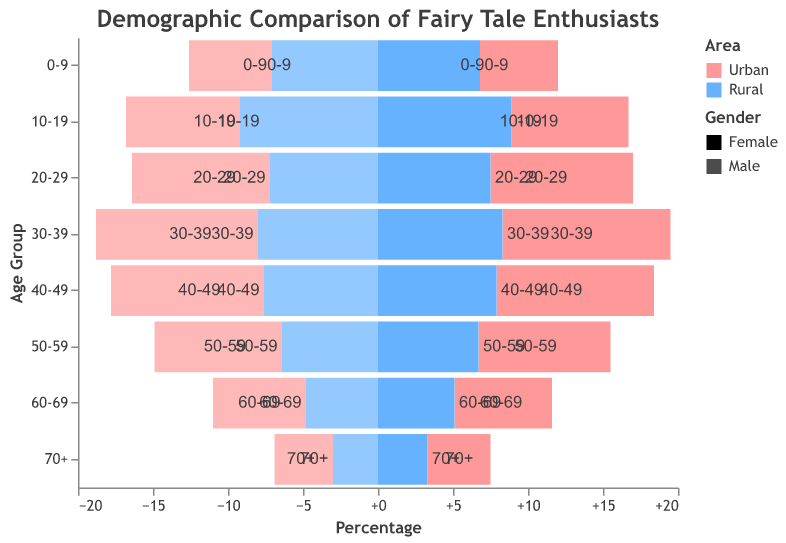What is the title of the figure? The title is usually displayed at the top of the figure and describes the main subject.
Answer: Demographic Comparison of Fairy Tale Enthusiasts Which age group has the highest percentage of urban females? To identify the age group, look for the longest bar on the left side (positive values) associated with urban females.
Answer: 30-39 In the age group 10-19, which area has a higher percentage of males who are fairy tale enthusiasts? Compare the lengths of the bars representing male percentages for urban and rural in the 10-19 age group. The lower part of the graph shows males, where negative values indicate males.
Answer: Rural How does the percentage of rural males compare to rural females in the age group 50-59? Compare the lengths of the bars for rural males and rural females within the age group 50-59. The bars for males have negative values, whereas those for females have positive values.
Answer: Rural males have a lower percentage than rural females Compare the overall trends in fairy tale enthusiasm between urban and rural areas across age groups. This requires looking at the general direction and magnitude of the bars for both urban and rural areas across all age groups.
Answer: Urban areas have higher percentages in the younger and middle age groups, while rural areas have higher percentages in the youngest groups and slightly in the 10-19 age group Which gender has a higher percentage of fairy tale enthusiasts in the urban population aged 20-29? Compare the lengths of the bars for urban males and urban females within the age group 20-29. The bars for males have negative values, whereas those for females have positive values.
Answer: Female What is the overall visual difference between lovers of fairy tales in rural and urban areas for the age group 70+? Compare the lengths of the bars on both sides of the axis for the 70+ age group for urban and rural areas. Urban figures tend to have fuller bars compared to their rural counterparts.
Answer: Urban lovers of fairy tales are more represented than rural In the 30-39 age group, how much higher is the percentage of urban males compared to rural males? Find the urban male percentage for 30-39 and the rural male percentage, then subtract the rural percentage from the urban percentage.
Answer: 2.8% Which age group shows the least difference between urban and rural females? Identify the age groups where the lengths of the urban and rural female bars are most similar and calculate the differences.
Answer: 70+ Considering the entire population pyramid, do urban or rural areas have a wider base indicating a younger population overall? A wider base indicates a larger percentage in the youngest age groups. Compare the lengths of the bars in the 0-9 and 10-19 groups for both areas.
Answer: Rural areas 